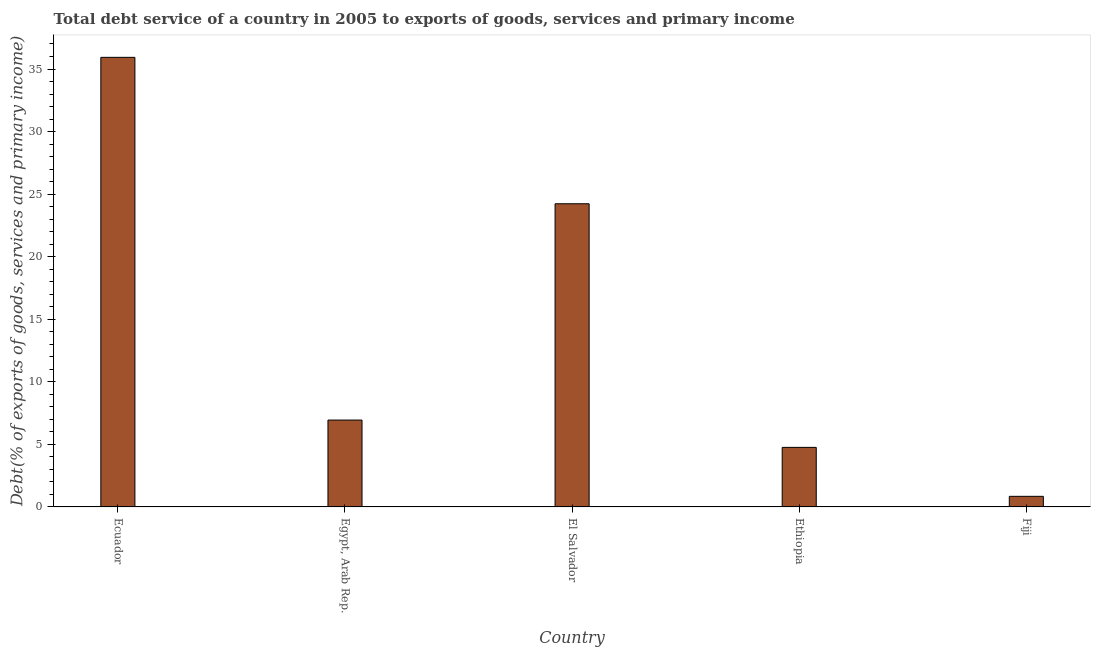Does the graph contain grids?
Make the answer very short. No. What is the title of the graph?
Provide a succinct answer. Total debt service of a country in 2005 to exports of goods, services and primary income. What is the label or title of the X-axis?
Ensure brevity in your answer.  Country. What is the label or title of the Y-axis?
Offer a terse response. Debt(% of exports of goods, services and primary income). What is the total debt service in Fiji?
Keep it short and to the point. 0.85. Across all countries, what is the maximum total debt service?
Provide a short and direct response. 35.93. Across all countries, what is the minimum total debt service?
Offer a terse response. 0.85. In which country was the total debt service maximum?
Provide a short and direct response. Ecuador. In which country was the total debt service minimum?
Provide a short and direct response. Fiji. What is the sum of the total debt service?
Provide a succinct answer. 72.71. What is the difference between the total debt service in Egypt, Arab Rep. and Fiji?
Ensure brevity in your answer.  6.1. What is the average total debt service per country?
Provide a succinct answer. 14.54. What is the median total debt service?
Keep it short and to the point. 6.94. In how many countries, is the total debt service greater than 23 %?
Your answer should be very brief. 2. What is the ratio of the total debt service in El Salvador to that in Fiji?
Ensure brevity in your answer.  28.63. Is the total debt service in Ecuador less than that in Ethiopia?
Offer a terse response. No. Is the difference between the total debt service in Ecuador and Fiji greater than the difference between any two countries?
Offer a terse response. Yes. What is the difference between the highest and the second highest total debt service?
Provide a succinct answer. 11.7. Is the sum of the total debt service in Egypt, Arab Rep. and Fiji greater than the maximum total debt service across all countries?
Your response must be concise. No. What is the difference between the highest and the lowest total debt service?
Offer a very short reply. 35.09. In how many countries, is the total debt service greater than the average total debt service taken over all countries?
Your response must be concise. 2. How many bars are there?
Offer a terse response. 5. Are all the bars in the graph horizontal?
Your answer should be compact. No. What is the Debt(% of exports of goods, services and primary income) in Ecuador?
Give a very brief answer. 35.93. What is the Debt(% of exports of goods, services and primary income) in Egypt, Arab Rep.?
Offer a very short reply. 6.94. What is the Debt(% of exports of goods, services and primary income) in El Salvador?
Provide a succinct answer. 24.23. What is the Debt(% of exports of goods, services and primary income) in Ethiopia?
Keep it short and to the point. 4.76. What is the Debt(% of exports of goods, services and primary income) in Fiji?
Offer a very short reply. 0.85. What is the difference between the Debt(% of exports of goods, services and primary income) in Ecuador and Egypt, Arab Rep.?
Your answer should be compact. 28.99. What is the difference between the Debt(% of exports of goods, services and primary income) in Ecuador and El Salvador?
Provide a short and direct response. 11.7. What is the difference between the Debt(% of exports of goods, services and primary income) in Ecuador and Ethiopia?
Your answer should be very brief. 31.17. What is the difference between the Debt(% of exports of goods, services and primary income) in Ecuador and Fiji?
Make the answer very short. 35.09. What is the difference between the Debt(% of exports of goods, services and primary income) in Egypt, Arab Rep. and El Salvador?
Make the answer very short. -17.29. What is the difference between the Debt(% of exports of goods, services and primary income) in Egypt, Arab Rep. and Ethiopia?
Your response must be concise. 2.18. What is the difference between the Debt(% of exports of goods, services and primary income) in Egypt, Arab Rep. and Fiji?
Your answer should be very brief. 6.1. What is the difference between the Debt(% of exports of goods, services and primary income) in El Salvador and Ethiopia?
Keep it short and to the point. 19.47. What is the difference between the Debt(% of exports of goods, services and primary income) in El Salvador and Fiji?
Your answer should be compact. 23.38. What is the difference between the Debt(% of exports of goods, services and primary income) in Ethiopia and Fiji?
Your response must be concise. 3.91. What is the ratio of the Debt(% of exports of goods, services and primary income) in Ecuador to that in Egypt, Arab Rep.?
Make the answer very short. 5.18. What is the ratio of the Debt(% of exports of goods, services and primary income) in Ecuador to that in El Salvador?
Keep it short and to the point. 1.48. What is the ratio of the Debt(% of exports of goods, services and primary income) in Ecuador to that in Ethiopia?
Provide a succinct answer. 7.55. What is the ratio of the Debt(% of exports of goods, services and primary income) in Ecuador to that in Fiji?
Give a very brief answer. 42.46. What is the ratio of the Debt(% of exports of goods, services and primary income) in Egypt, Arab Rep. to that in El Salvador?
Ensure brevity in your answer.  0.29. What is the ratio of the Debt(% of exports of goods, services and primary income) in Egypt, Arab Rep. to that in Ethiopia?
Your response must be concise. 1.46. What is the ratio of the Debt(% of exports of goods, services and primary income) in Egypt, Arab Rep. to that in Fiji?
Ensure brevity in your answer.  8.2. What is the ratio of the Debt(% of exports of goods, services and primary income) in El Salvador to that in Ethiopia?
Provide a short and direct response. 5.09. What is the ratio of the Debt(% of exports of goods, services and primary income) in El Salvador to that in Fiji?
Make the answer very short. 28.63. What is the ratio of the Debt(% of exports of goods, services and primary income) in Ethiopia to that in Fiji?
Your answer should be very brief. 5.62. 